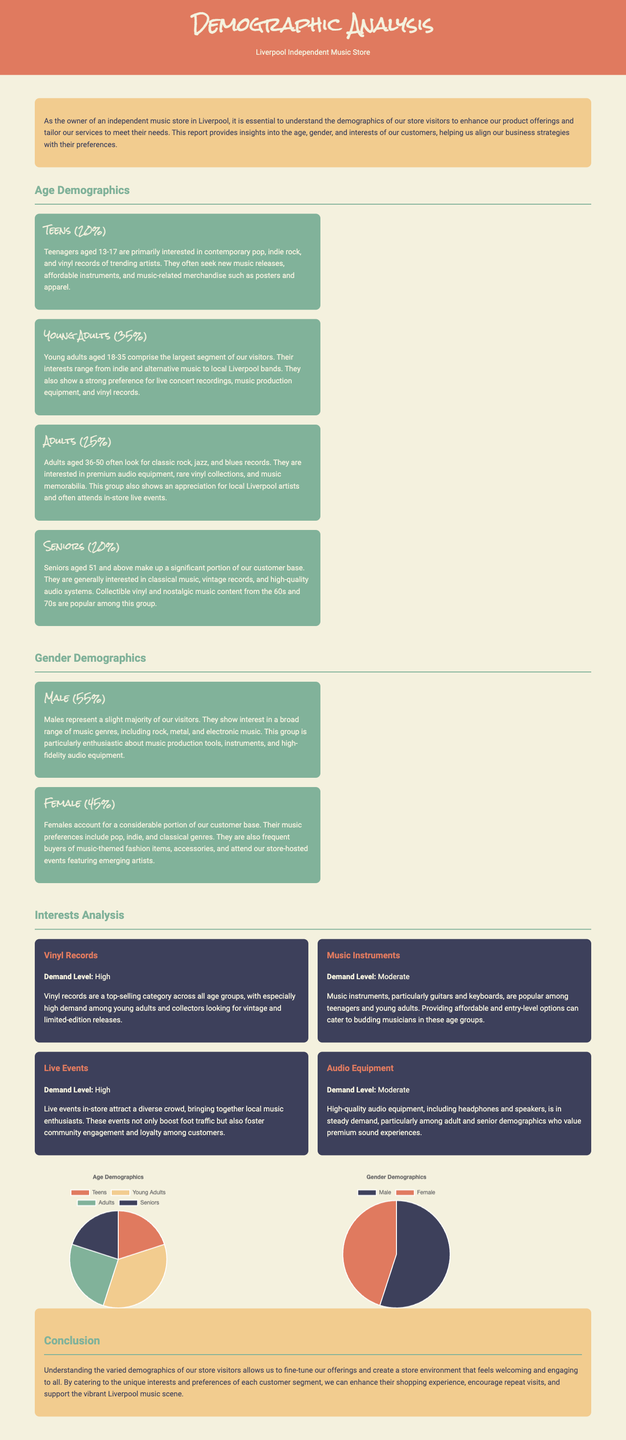What age group comprises the largest segment of store visitors? The largest segment of store visitors is identified as young adults aged 18-35, which is 35%.
Answer: Young Adults (35%) What is the gender demographic percentage for females? The document states that females account for 45% of the customer base.
Answer: 45% What type of music are seniors primarily interested in? Seniors aged 51 and above are generally interested in classical music, vintage records, and high-quality audio systems.
Answer: Classical music What is the demand level for live events? The document indicates that live events are in high demand across the diverse crowd visiting the store.
Answer: High What percentage of visitors are teenagers? The report highlights that teenagers make up 20% of the visitors to the store.
Answer: 20% Which age group is noted for showing interest in music production equipment? The report mentions that young adults aged 18-35 display a strong interest in music production equipment.
Answer: Young Adults (18-35) What music genres are adults interested in according to the report? Adults aged 36-50 are interested in classic rock, jazz, and blues records.
Answer: Classic rock, jazz, blues What percentage of visitors are male? The document states that males constitute 55% of the store's visitors.
Answer: 55% Which demographic group shows high demand for vinyl records? The document mentions that vinyl records have especially high demand among young adults and collectors.
Answer: Young Adults 